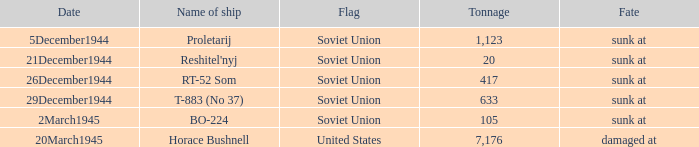What was the end of service for the ship known as proletarij? Sunk at. 